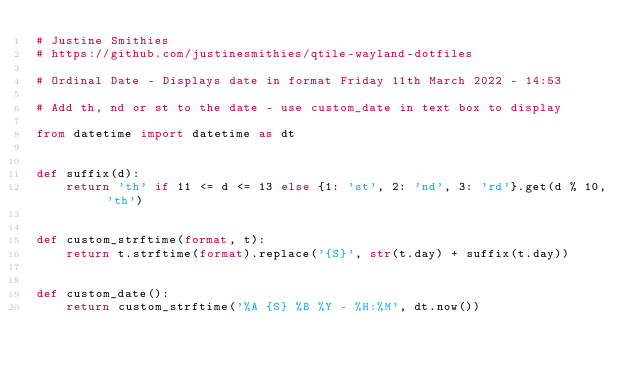Convert code to text. <code><loc_0><loc_0><loc_500><loc_500><_Python_># Justine Smithies
# https://github.com/justinesmithies/qtile-wayland-dotfiles

# Ordinal Date - Displays date in format Friday 11th March 2022 - 14:53

# Add th, nd or st to the date - use custom_date in text box to display

from datetime import datetime as dt


def suffix(d):
    return 'th' if 11 <= d <= 13 else {1: 'st', 2: 'nd', 3: 'rd'}.get(d % 10, 'th')


def custom_strftime(format, t):
    return t.strftime(format).replace('{S}', str(t.day) + suffix(t.day))


def custom_date():
    return custom_strftime('%A {S} %B %Y - %H:%M', dt.now())
</code> 